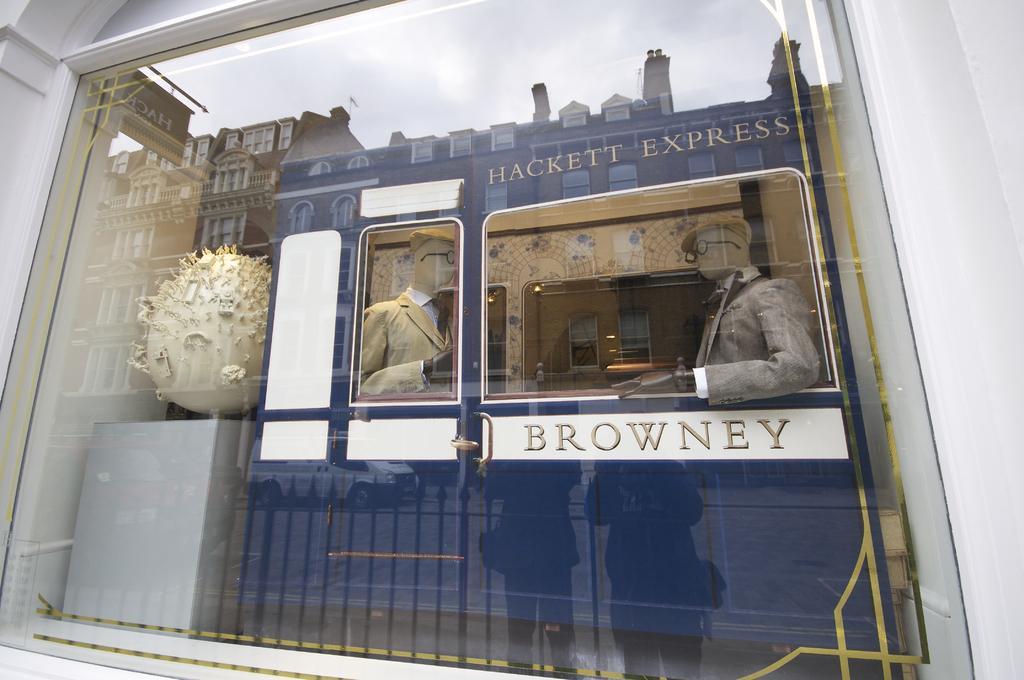Please provide a concise description of this image. In the foreground of this image, there is a glass and inside the glass there are mannequins and a globe like structure. In the reflection of the glass, we can see the sky, buildings, a vehicle and two people standing on the side path. 